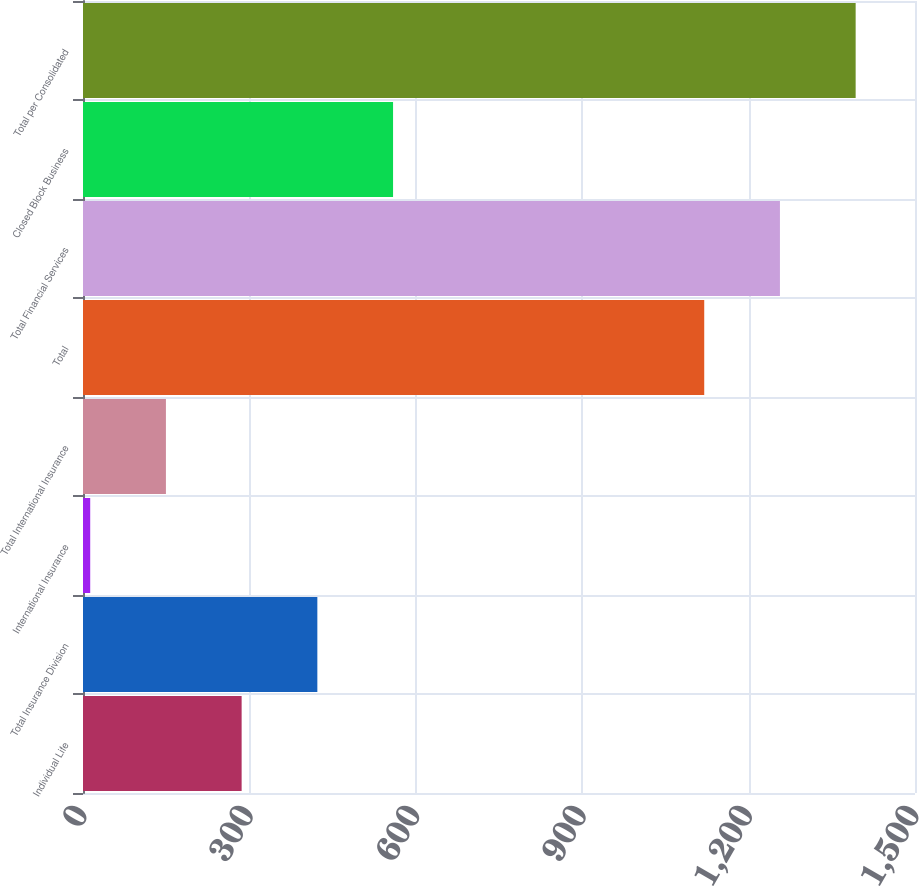Convert chart. <chart><loc_0><loc_0><loc_500><loc_500><bar_chart><fcel>Individual Life<fcel>Total Insurance Division<fcel>International Insurance<fcel>Total International Insurance<fcel>Total<fcel>Total Financial Services<fcel>Closed Block Business<fcel>Total per Consolidated<nl><fcel>286<fcel>422.5<fcel>13<fcel>149.5<fcel>1120<fcel>1256.5<fcel>559<fcel>1393<nl></chart> 